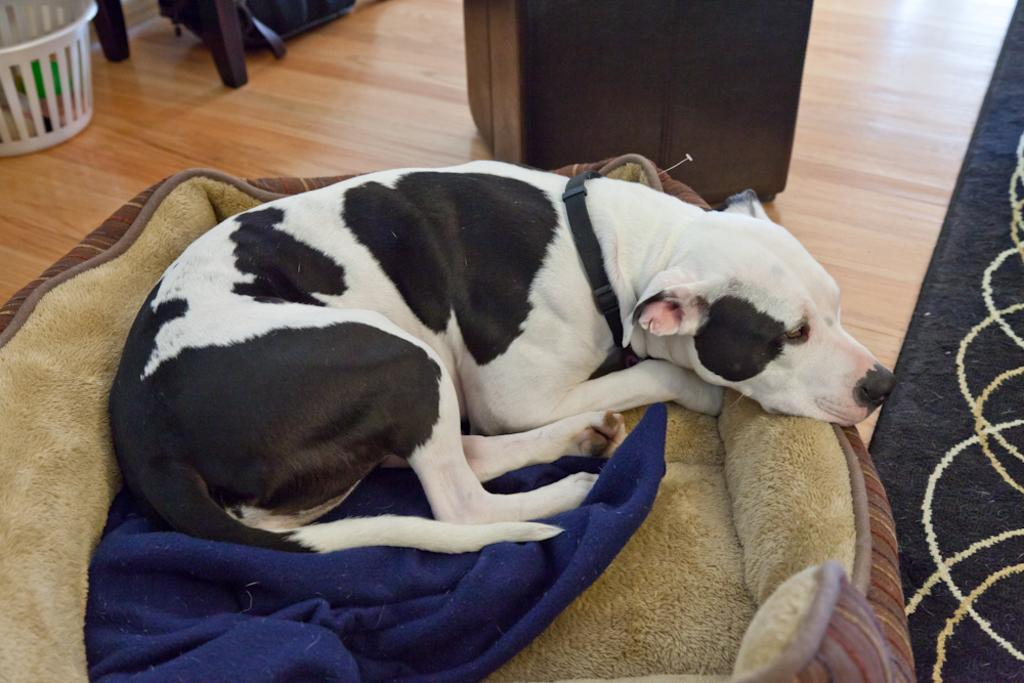What type of animal is in the image? There is a dog in the image. Where is the dog located? The dog is on a pet bed. What other furniture or objects can be seen in the image? There is a basket and a cupboard in the image. What else is on the floor in the image? There are other objects on the floor in the image. How deep is the hole that the dog is digging in the image? There is no hole present in the image; the dog is on a pet bed. What color is the balloon that the dog is holding in the image? There is no balloon present in the image; the dog is on a pet bed. 